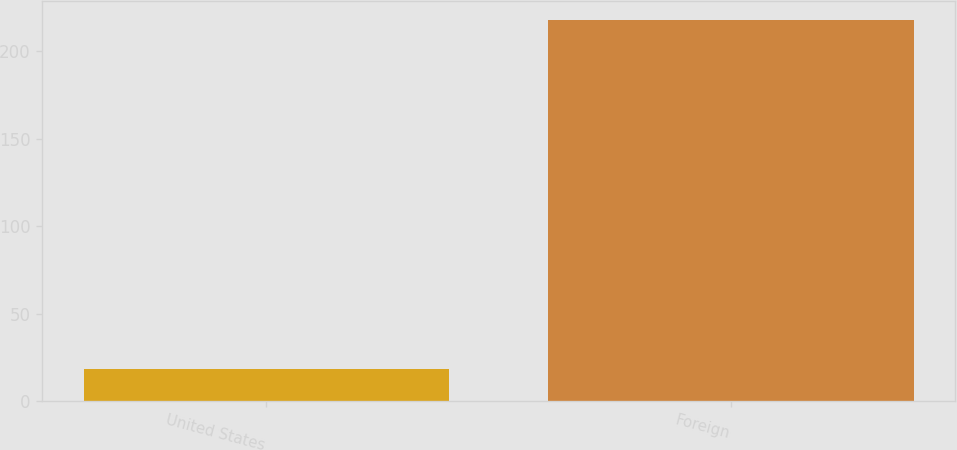Convert chart. <chart><loc_0><loc_0><loc_500><loc_500><bar_chart><fcel>United States<fcel>Foreign<nl><fcel>18<fcel>218<nl></chart> 